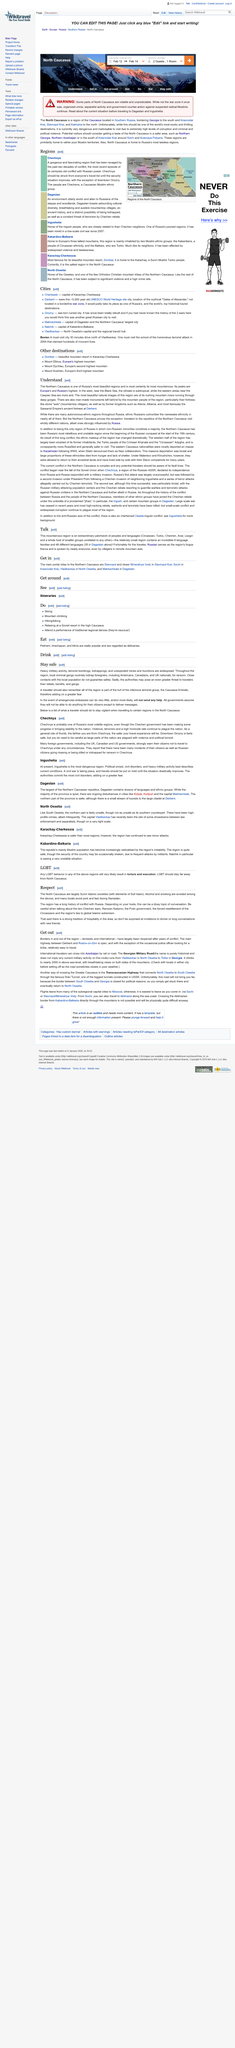Indicate a few pertinent items in this graphic. It is not safe to travel to Chechnya until the security situation improves. The main highway between Derbent and Rostov-on-Don is open, and it is confirmed that it is accessible. The North Caucasian Republic country that is currently deemed the safest for travelers between Dagestan and Ingushetia is Dagestan. Dagestan is the largest of the Northern Caucasian Republics, making it the largest country in this region. The Sassanid Empire's ancient fortress, located in Derbent, is a testament to the advanced civilization that once flourished in the region. 